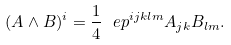Convert formula to latex. <formula><loc_0><loc_0><loc_500><loc_500>( A \wedge B ) ^ { i } = \frac { 1 } { 4 } \ e p ^ { i j k l m } A _ { j k } B _ { l m } .</formula> 